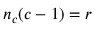<formula> <loc_0><loc_0><loc_500><loc_500>n _ { c } ( c - 1 ) = r</formula> 